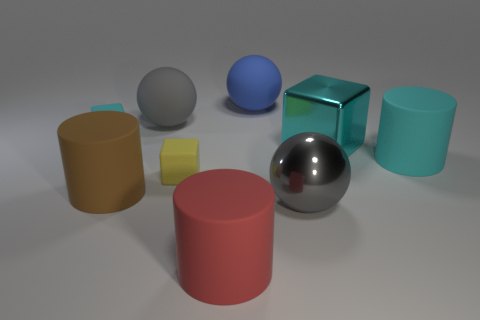Subtract all rubber balls. How many balls are left? 1 Add 1 big gray shiny things. How many big gray shiny things are left? 2 Add 4 metallic cylinders. How many metallic cylinders exist? 4 Subtract all gray balls. How many balls are left? 1 Subtract 0 green balls. How many objects are left? 9 Subtract all cylinders. How many objects are left? 6 Subtract 2 cylinders. How many cylinders are left? 1 Subtract all blue balls. Subtract all cyan cylinders. How many balls are left? 2 Subtract all gray cubes. How many cyan cylinders are left? 1 Subtract all large matte things. Subtract all blue metallic balls. How many objects are left? 4 